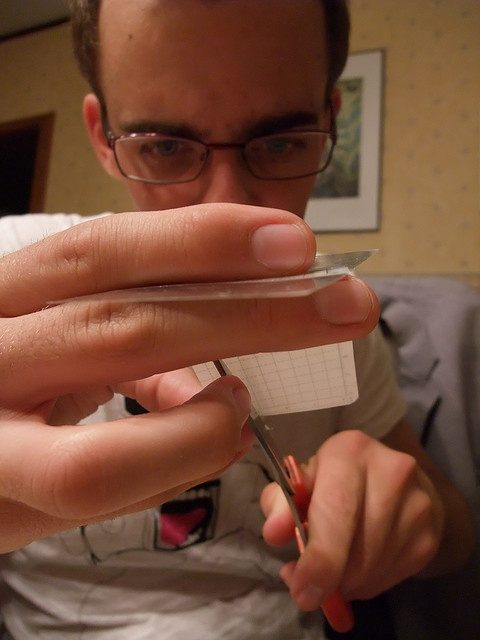Describe the objects in this image and their specific colors. I can see people in black, maroon, and brown tones, bed in black, gray, and maroon tones, and scissors in black, maroon, and brown tones in this image. 